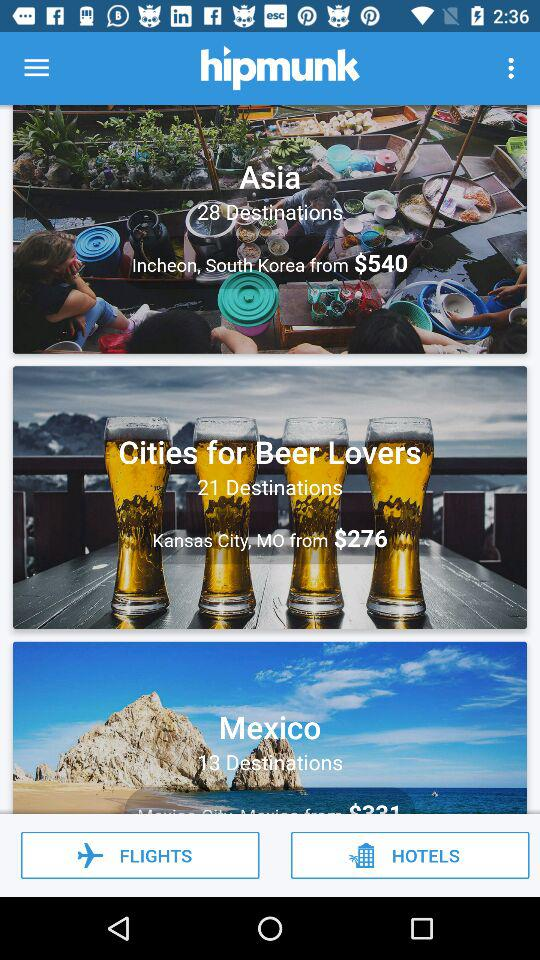How many destinations are there for beer lovers? There are 21 destinations for beer lovers. 